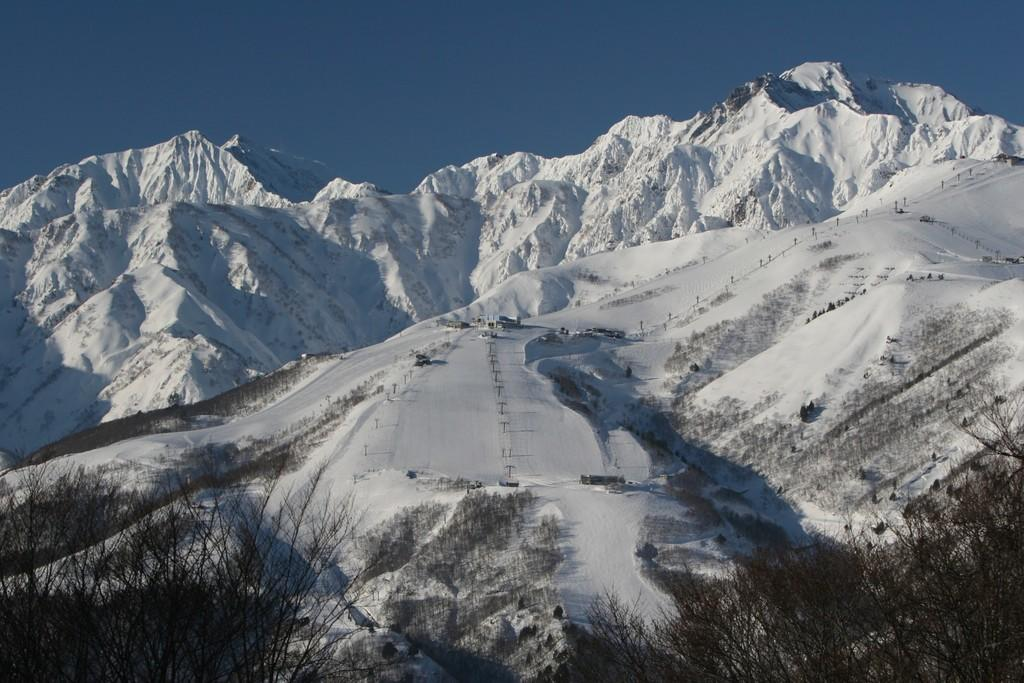What type of vegetation is visible in the front of the image? There are trees in the front of the image. What type of natural formation can be seen in the background of the image? There are mountains in the background of the image. Can you see any stems on the trees in the image? The image does not show any close-up details of the trees, so it is not possible to determine if there are stems visible. Are there any animals with fangs visible in the image? There are no animals, with or without fangs, present in the image. 